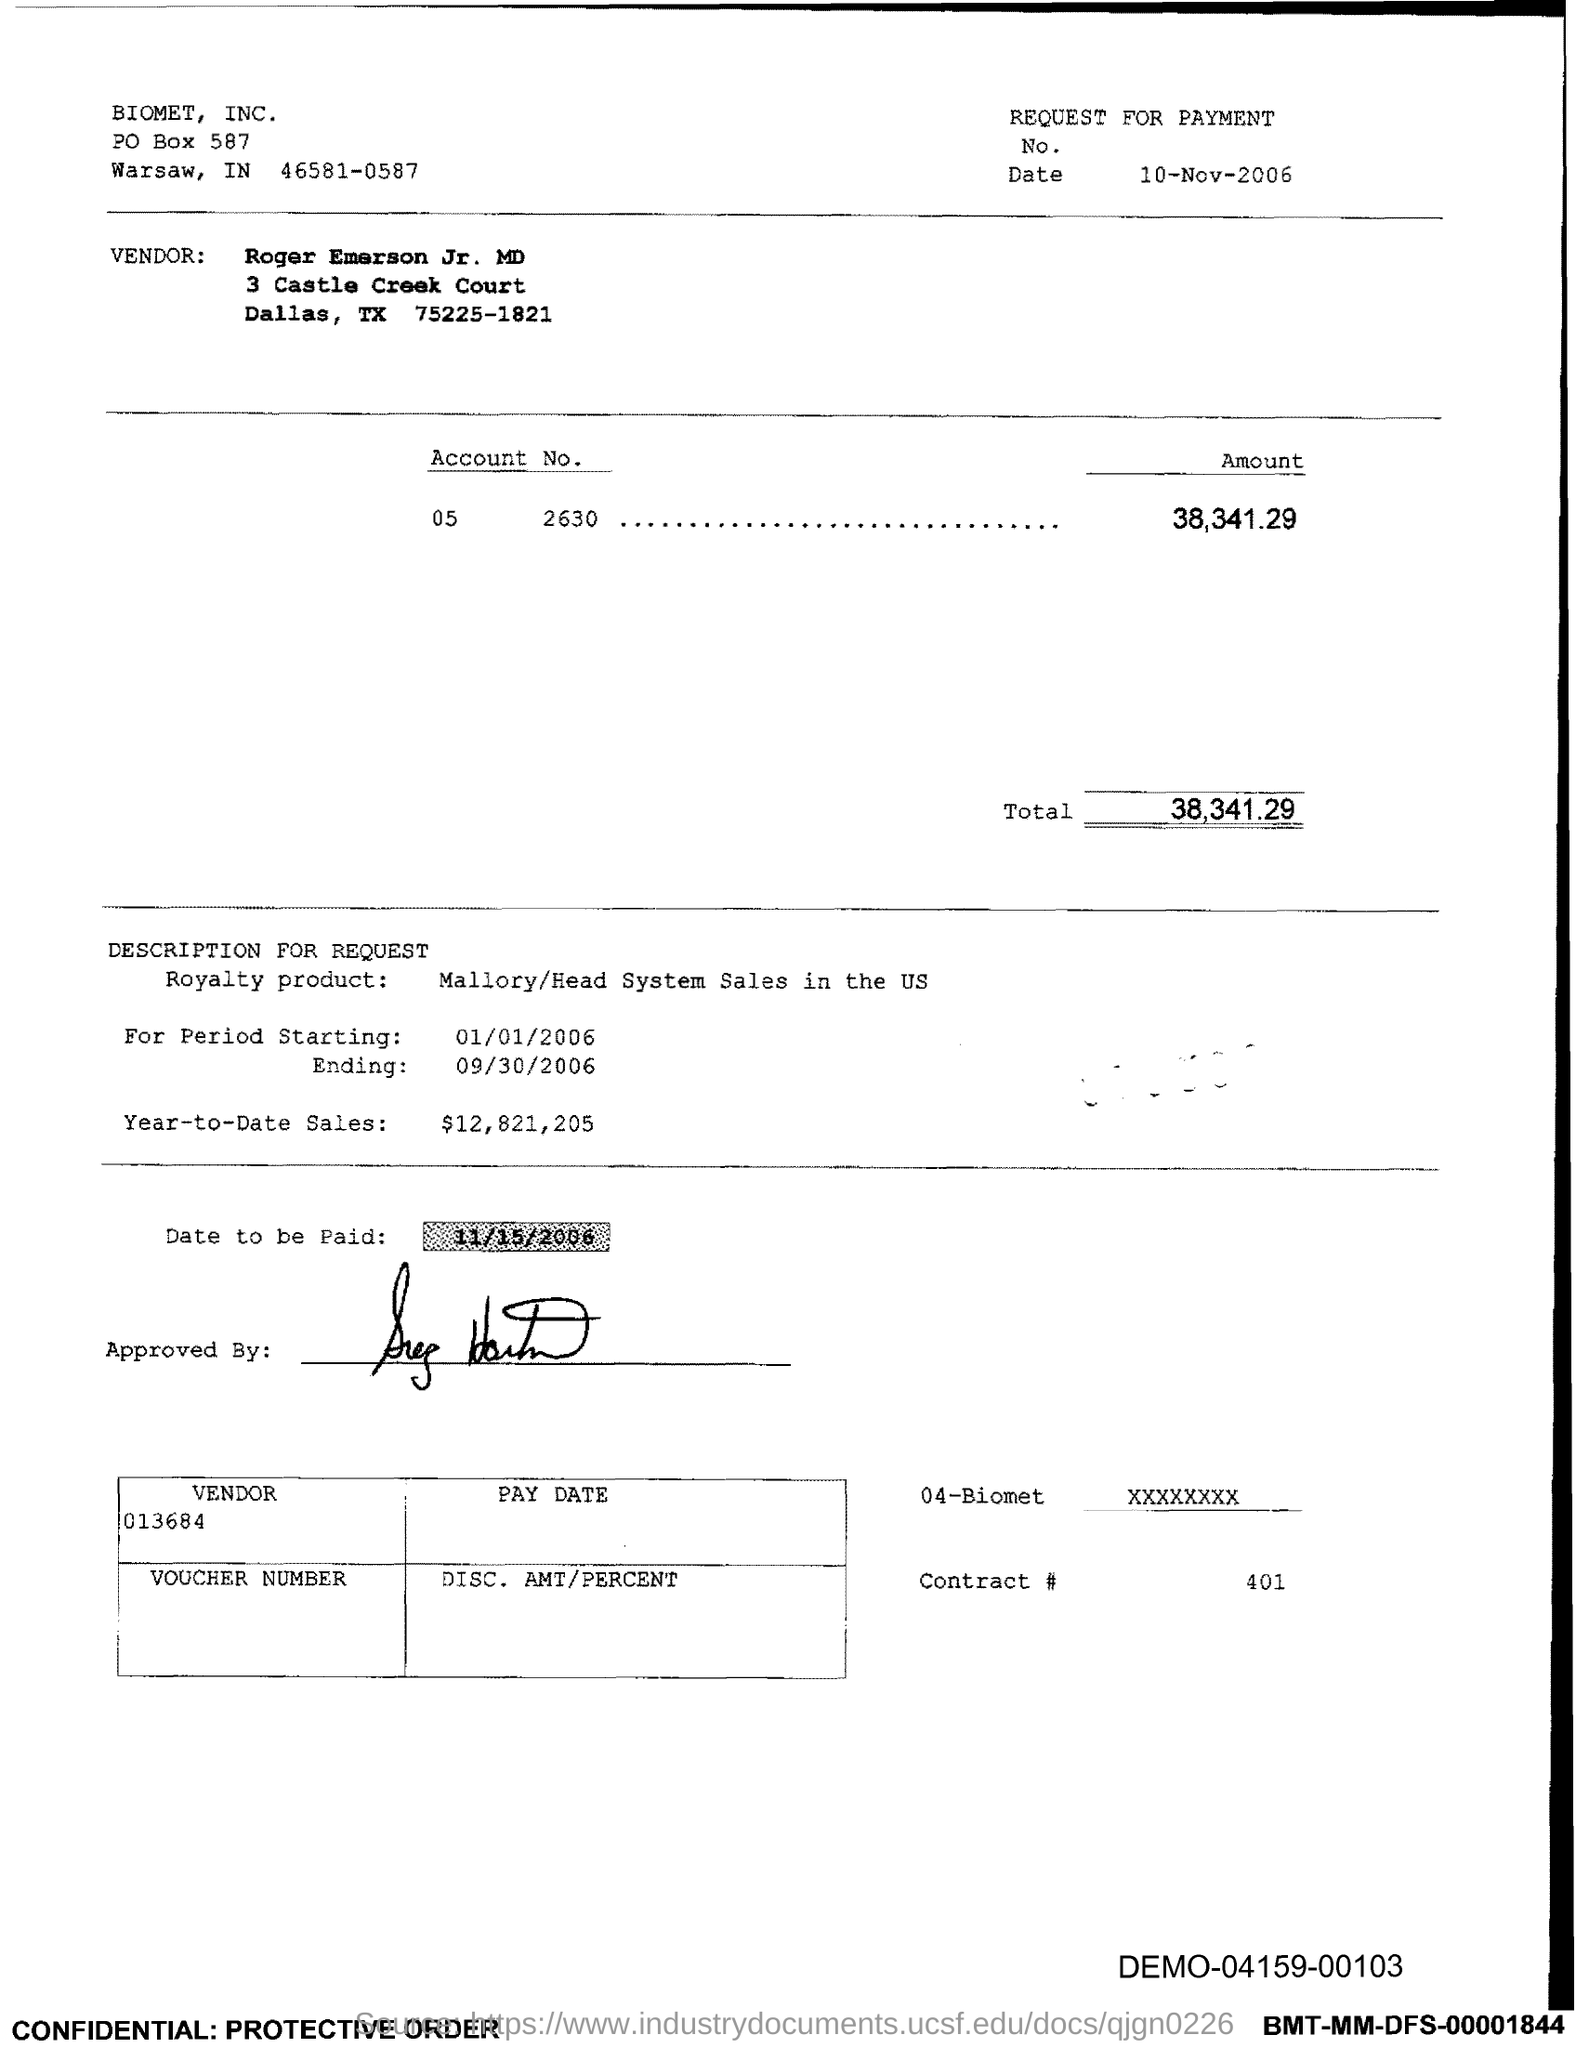What is the Contract # Number?
Make the answer very short. 401. What is the Total?
Give a very brief answer. 38,341.29. 